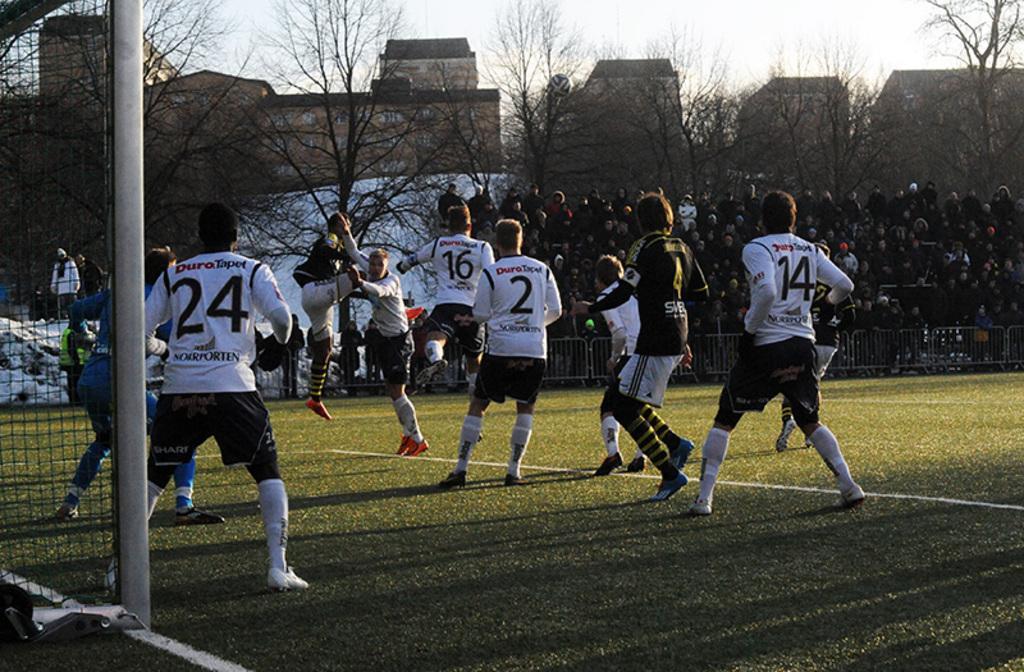In one or two sentences, can you explain what this image depicts? This picture shows few players playing football and we see audience watching and we see trees and buildings and we see a cloudy sky. 